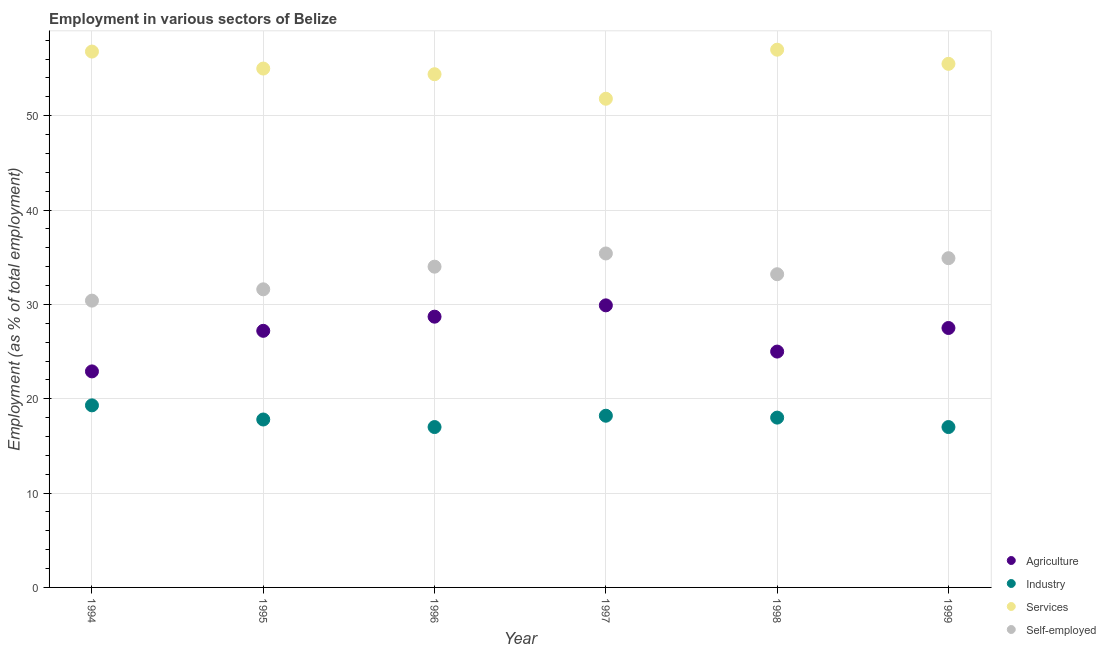Is the number of dotlines equal to the number of legend labels?
Offer a very short reply. Yes. What is the percentage of workers in agriculture in 1994?
Ensure brevity in your answer.  22.9. Across all years, what is the minimum percentage of self employed workers?
Your answer should be very brief. 30.4. In which year was the percentage of workers in agriculture maximum?
Your response must be concise. 1997. In which year was the percentage of self employed workers minimum?
Make the answer very short. 1994. What is the total percentage of workers in industry in the graph?
Your response must be concise. 107.3. What is the difference between the percentage of self employed workers in 1995 and that in 1997?
Offer a very short reply. -3.8. What is the difference between the percentage of workers in services in 1998 and the percentage of workers in industry in 1996?
Your answer should be very brief. 40. What is the average percentage of workers in services per year?
Offer a very short reply. 55.08. In the year 1995, what is the difference between the percentage of workers in services and percentage of workers in industry?
Keep it short and to the point. 37.2. What is the ratio of the percentage of self employed workers in 1995 to that in 1998?
Offer a very short reply. 0.95. Is the percentage of workers in industry in 1998 less than that in 1999?
Give a very brief answer. No. What is the difference between the highest and the second highest percentage of self employed workers?
Your response must be concise. 0.5. What is the difference between the highest and the lowest percentage of workers in industry?
Make the answer very short. 2.3. In how many years, is the percentage of workers in agriculture greater than the average percentage of workers in agriculture taken over all years?
Give a very brief answer. 4. Is it the case that in every year, the sum of the percentage of workers in agriculture and percentage of workers in industry is greater than the sum of percentage of self employed workers and percentage of workers in services?
Your answer should be compact. No. Is it the case that in every year, the sum of the percentage of workers in agriculture and percentage of workers in industry is greater than the percentage of workers in services?
Your answer should be very brief. No. Is the percentage of workers in industry strictly greater than the percentage of self employed workers over the years?
Offer a terse response. No. Is the percentage of workers in industry strictly less than the percentage of workers in agriculture over the years?
Your answer should be compact. Yes. How many dotlines are there?
Offer a very short reply. 4. How many years are there in the graph?
Your response must be concise. 6. Are the values on the major ticks of Y-axis written in scientific E-notation?
Your answer should be compact. No. Does the graph contain grids?
Keep it short and to the point. Yes. Where does the legend appear in the graph?
Your response must be concise. Bottom right. How many legend labels are there?
Offer a very short reply. 4. What is the title of the graph?
Make the answer very short. Employment in various sectors of Belize. Does "Tertiary education" appear as one of the legend labels in the graph?
Your response must be concise. No. What is the label or title of the Y-axis?
Your response must be concise. Employment (as % of total employment). What is the Employment (as % of total employment) in Agriculture in 1994?
Offer a terse response. 22.9. What is the Employment (as % of total employment) of Industry in 1994?
Keep it short and to the point. 19.3. What is the Employment (as % of total employment) in Services in 1994?
Your answer should be compact. 56.8. What is the Employment (as % of total employment) in Self-employed in 1994?
Keep it short and to the point. 30.4. What is the Employment (as % of total employment) in Agriculture in 1995?
Keep it short and to the point. 27.2. What is the Employment (as % of total employment) of Industry in 1995?
Make the answer very short. 17.8. What is the Employment (as % of total employment) in Services in 1995?
Offer a very short reply. 55. What is the Employment (as % of total employment) of Self-employed in 1995?
Provide a short and direct response. 31.6. What is the Employment (as % of total employment) of Agriculture in 1996?
Provide a short and direct response. 28.7. What is the Employment (as % of total employment) of Services in 1996?
Make the answer very short. 54.4. What is the Employment (as % of total employment) in Self-employed in 1996?
Give a very brief answer. 34. What is the Employment (as % of total employment) of Agriculture in 1997?
Ensure brevity in your answer.  29.9. What is the Employment (as % of total employment) in Industry in 1997?
Your answer should be very brief. 18.2. What is the Employment (as % of total employment) in Services in 1997?
Offer a very short reply. 51.8. What is the Employment (as % of total employment) of Self-employed in 1997?
Make the answer very short. 35.4. What is the Employment (as % of total employment) of Services in 1998?
Your response must be concise. 57. What is the Employment (as % of total employment) of Self-employed in 1998?
Offer a terse response. 33.2. What is the Employment (as % of total employment) of Agriculture in 1999?
Your response must be concise. 27.5. What is the Employment (as % of total employment) in Services in 1999?
Make the answer very short. 55.5. What is the Employment (as % of total employment) of Self-employed in 1999?
Your answer should be compact. 34.9. Across all years, what is the maximum Employment (as % of total employment) of Agriculture?
Provide a short and direct response. 29.9. Across all years, what is the maximum Employment (as % of total employment) of Industry?
Offer a very short reply. 19.3. Across all years, what is the maximum Employment (as % of total employment) in Services?
Keep it short and to the point. 57. Across all years, what is the maximum Employment (as % of total employment) of Self-employed?
Give a very brief answer. 35.4. Across all years, what is the minimum Employment (as % of total employment) in Agriculture?
Offer a terse response. 22.9. Across all years, what is the minimum Employment (as % of total employment) in Industry?
Ensure brevity in your answer.  17. Across all years, what is the minimum Employment (as % of total employment) of Services?
Provide a succinct answer. 51.8. Across all years, what is the minimum Employment (as % of total employment) of Self-employed?
Your response must be concise. 30.4. What is the total Employment (as % of total employment) of Agriculture in the graph?
Your answer should be very brief. 161.2. What is the total Employment (as % of total employment) of Industry in the graph?
Your answer should be very brief. 107.3. What is the total Employment (as % of total employment) in Services in the graph?
Your answer should be very brief. 330.5. What is the total Employment (as % of total employment) in Self-employed in the graph?
Provide a short and direct response. 199.5. What is the difference between the Employment (as % of total employment) in Industry in 1994 and that in 1995?
Ensure brevity in your answer.  1.5. What is the difference between the Employment (as % of total employment) in Services in 1994 and that in 1995?
Offer a very short reply. 1.8. What is the difference between the Employment (as % of total employment) in Agriculture in 1994 and that in 1996?
Keep it short and to the point. -5.8. What is the difference between the Employment (as % of total employment) of Services in 1994 and that in 1996?
Give a very brief answer. 2.4. What is the difference between the Employment (as % of total employment) of Self-employed in 1994 and that in 1996?
Provide a short and direct response. -3.6. What is the difference between the Employment (as % of total employment) in Agriculture in 1994 and that in 1997?
Ensure brevity in your answer.  -7. What is the difference between the Employment (as % of total employment) in Industry in 1994 and that in 1997?
Your response must be concise. 1.1. What is the difference between the Employment (as % of total employment) in Services in 1994 and that in 1997?
Offer a terse response. 5. What is the difference between the Employment (as % of total employment) of Agriculture in 1994 and that in 1998?
Ensure brevity in your answer.  -2.1. What is the difference between the Employment (as % of total employment) in Industry in 1994 and that in 1998?
Make the answer very short. 1.3. What is the difference between the Employment (as % of total employment) in Self-employed in 1994 and that in 1998?
Your response must be concise. -2.8. What is the difference between the Employment (as % of total employment) of Industry in 1994 and that in 1999?
Ensure brevity in your answer.  2.3. What is the difference between the Employment (as % of total employment) in Self-employed in 1994 and that in 1999?
Your answer should be very brief. -4.5. What is the difference between the Employment (as % of total employment) of Agriculture in 1995 and that in 1998?
Keep it short and to the point. 2.2. What is the difference between the Employment (as % of total employment) in Industry in 1995 and that in 1998?
Your response must be concise. -0.2. What is the difference between the Employment (as % of total employment) of Services in 1995 and that in 1998?
Keep it short and to the point. -2. What is the difference between the Employment (as % of total employment) in Agriculture in 1995 and that in 1999?
Your response must be concise. -0.3. What is the difference between the Employment (as % of total employment) in Services in 1995 and that in 1999?
Your answer should be very brief. -0.5. What is the difference between the Employment (as % of total employment) of Agriculture in 1996 and that in 1997?
Provide a short and direct response. -1.2. What is the difference between the Employment (as % of total employment) of Industry in 1996 and that in 1997?
Offer a terse response. -1.2. What is the difference between the Employment (as % of total employment) of Industry in 1996 and that in 1998?
Ensure brevity in your answer.  -1. What is the difference between the Employment (as % of total employment) of Services in 1996 and that in 1998?
Provide a succinct answer. -2.6. What is the difference between the Employment (as % of total employment) of Agriculture in 1996 and that in 1999?
Give a very brief answer. 1.2. What is the difference between the Employment (as % of total employment) of Agriculture in 1997 and that in 1998?
Provide a short and direct response. 4.9. What is the difference between the Employment (as % of total employment) in Industry in 1997 and that in 1998?
Offer a very short reply. 0.2. What is the difference between the Employment (as % of total employment) of Services in 1997 and that in 1998?
Offer a very short reply. -5.2. What is the difference between the Employment (as % of total employment) in Self-employed in 1997 and that in 1998?
Your response must be concise. 2.2. What is the difference between the Employment (as % of total employment) of Industry in 1997 and that in 1999?
Make the answer very short. 1.2. What is the difference between the Employment (as % of total employment) in Services in 1997 and that in 1999?
Provide a succinct answer. -3.7. What is the difference between the Employment (as % of total employment) of Self-employed in 1997 and that in 1999?
Your answer should be compact. 0.5. What is the difference between the Employment (as % of total employment) in Agriculture in 1998 and that in 1999?
Make the answer very short. -2.5. What is the difference between the Employment (as % of total employment) of Industry in 1998 and that in 1999?
Offer a very short reply. 1. What is the difference between the Employment (as % of total employment) in Services in 1998 and that in 1999?
Make the answer very short. 1.5. What is the difference between the Employment (as % of total employment) of Agriculture in 1994 and the Employment (as % of total employment) of Services in 1995?
Provide a succinct answer. -32.1. What is the difference between the Employment (as % of total employment) of Industry in 1994 and the Employment (as % of total employment) of Services in 1995?
Keep it short and to the point. -35.7. What is the difference between the Employment (as % of total employment) of Industry in 1994 and the Employment (as % of total employment) of Self-employed in 1995?
Provide a short and direct response. -12.3. What is the difference between the Employment (as % of total employment) in Services in 1994 and the Employment (as % of total employment) in Self-employed in 1995?
Your answer should be very brief. 25.2. What is the difference between the Employment (as % of total employment) of Agriculture in 1994 and the Employment (as % of total employment) of Industry in 1996?
Your answer should be compact. 5.9. What is the difference between the Employment (as % of total employment) in Agriculture in 1994 and the Employment (as % of total employment) in Services in 1996?
Give a very brief answer. -31.5. What is the difference between the Employment (as % of total employment) of Agriculture in 1994 and the Employment (as % of total employment) of Self-employed in 1996?
Offer a very short reply. -11.1. What is the difference between the Employment (as % of total employment) of Industry in 1994 and the Employment (as % of total employment) of Services in 1996?
Your response must be concise. -35.1. What is the difference between the Employment (as % of total employment) in Industry in 1994 and the Employment (as % of total employment) in Self-employed in 1996?
Provide a succinct answer. -14.7. What is the difference between the Employment (as % of total employment) of Services in 1994 and the Employment (as % of total employment) of Self-employed in 1996?
Your response must be concise. 22.8. What is the difference between the Employment (as % of total employment) of Agriculture in 1994 and the Employment (as % of total employment) of Industry in 1997?
Provide a succinct answer. 4.7. What is the difference between the Employment (as % of total employment) of Agriculture in 1994 and the Employment (as % of total employment) of Services in 1997?
Make the answer very short. -28.9. What is the difference between the Employment (as % of total employment) in Agriculture in 1994 and the Employment (as % of total employment) in Self-employed in 1997?
Make the answer very short. -12.5. What is the difference between the Employment (as % of total employment) in Industry in 1994 and the Employment (as % of total employment) in Services in 1997?
Ensure brevity in your answer.  -32.5. What is the difference between the Employment (as % of total employment) of Industry in 1994 and the Employment (as % of total employment) of Self-employed in 1997?
Your response must be concise. -16.1. What is the difference between the Employment (as % of total employment) in Services in 1994 and the Employment (as % of total employment) in Self-employed in 1997?
Your answer should be compact. 21.4. What is the difference between the Employment (as % of total employment) in Agriculture in 1994 and the Employment (as % of total employment) in Industry in 1998?
Ensure brevity in your answer.  4.9. What is the difference between the Employment (as % of total employment) in Agriculture in 1994 and the Employment (as % of total employment) in Services in 1998?
Keep it short and to the point. -34.1. What is the difference between the Employment (as % of total employment) of Agriculture in 1994 and the Employment (as % of total employment) of Self-employed in 1998?
Give a very brief answer. -10.3. What is the difference between the Employment (as % of total employment) in Industry in 1994 and the Employment (as % of total employment) in Services in 1998?
Ensure brevity in your answer.  -37.7. What is the difference between the Employment (as % of total employment) of Services in 1994 and the Employment (as % of total employment) of Self-employed in 1998?
Offer a very short reply. 23.6. What is the difference between the Employment (as % of total employment) of Agriculture in 1994 and the Employment (as % of total employment) of Services in 1999?
Offer a terse response. -32.6. What is the difference between the Employment (as % of total employment) in Agriculture in 1994 and the Employment (as % of total employment) in Self-employed in 1999?
Your answer should be compact. -12. What is the difference between the Employment (as % of total employment) in Industry in 1994 and the Employment (as % of total employment) in Services in 1999?
Your response must be concise. -36.2. What is the difference between the Employment (as % of total employment) in Industry in 1994 and the Employment (as % of total employment) in Self-employed in 1999?
Keep it short and to the point. -15.6. What is the difference between the Employment (as % of total employment) in Services in 1994 and the Employment (as % of total employment) in Self-employed in 1999?
Provide a short and direct response. 21.9. What is the difference between the Employment (as % of total employment) in Agriculture in 1995 and the Employment (as % of total employment) in Industry in 1996?
Your answer should be compact. 10.2. What is the difference between the Employment (as % of total employment) of Agriculture in 1995 and the Employment (as % of total employment) of Services in 1996?
Your response must be concise. -27.2. What is the difference between the Employment (as % of total employment) of Agriculture in 1995 and the Employment (as % of total employment) of Self-employed in 1996?
Your answer should be compact. -6.8. What is the difference between the Employment (as % of total employment) in Industry in 1995 and the Employment (as % of total employment) in Services in 1996?
Make the answer very short. -36.6. What is the difference between the Employment (as % of total employment) of Industry in 1995 and the Employment (as % of total employment) of Self-employed in 1996?
Give a very brief answer. -16.2. What is the difference between the Employment (as % of total employment) in Agriculture in 1995 and the Employment (as % of total employment) in Services in 1997?
Your answer should be very brief. -24.6. What is the difference between the Employment (as % of total employment) in Industry in 1995 and the Employment (as % of total employment) in Services in 1997?
Your answer should be compact. -34. What is the difference between the Employment (as % of total employment) of Industry in 1995 and the Employment (as % of total employment) of Self-employed in 1997?
Provide a short and direct response. -17.6. What is the difference between the Employment (as % of total employment) of Services in 1995 and the Employment (as % of total employment) of Self-employed in 1997?
Ensure brevity in your answer.  19.6. What is the difference between the Employment (as % of total employment) in Agriculture in 1995 and the Employment (as % of total employment) in Services in 1998?
Your response must be concise. -29.8. What is the difference between the Employment (as % of total employment) in Industry in 1995 and the Employment (as % of total employment) in Services in 1998?
Give a very brief answer. -39.2. What is the difference between the Employment (as % of total employment) of Industry in 1995 and the Employment (as % of total employment) of Self-employed in 1998?
Your response must be concise. -15.4. What is the difference between the Employment (as % of total employment) in Services in 1995 and the Employment (as % of total employment) in Self-employed in 1998?
Your response must be concise. 21.8. What is the difference between the Employment (as % of total employment) of Agriculture in 1995 and the Employment (as % of total employment) of Services in 1999?
Your response must be concise. -28.3. What is the difference between the Employment (as % of total employment) in Industry in 1995 and the Employment (as % of total employment) in Services in 1999?
Provide a succinct answer. -37.7. What is the difference between the Employment (as % of total employment) of Industry in 1995 and the Employment (as % of total employment) of Self-employed in 1999?
Make the answer very short. -17.1. What is the difference between the Employment (as % of total employment) in Services in 1995 and the Employment (as % of total employment) in Self-employed in 1999?
Offer a very short reply. 20.1. What is the difference between the Employment (as % of total employment) in Agriculture in 1996 and the Employment (as % of total employment) in Industry in 1997?
Provide a succinct answer. 10.5. What is the difference between the Employment (as % of total employment) of Agriculture in 1996 and the Employment (as % of total employment) of Services in 1997?
Make the answer very short. -23.1. What is the difference between the Employment (as % of total employment) of Agriculture in 1996 and the Employment (as % of total employment) of Self-employed in 1997?
Your answer should be compact. -6.7. What is the difference between the Employment (as % of total employment) in Industry in 1996 and the Employment (as % of total employment) in Services in 1997?
Your answer should be very brief. -34.8. What is the difference between the Employment (as % of total employment) of Industry in 1996 and the Employment (as % of total employment) of Self-employed in 1997?
Offer a terse response. -18.4. What is the difference between the Employment (as % of total employment) of Services in 1996 and the Employment (as % of total employment) of Self-employed in 1997?
Your response must be concise. 19. What is the difference between the Employment (as % of total employment) of Agriculture in 1996 and the Employment (as % of total employment) of Industry in 1998?
Make the answer very short. 10.7. What is the difference between the Employment (as % of total employment) of Agriculture in 1996 and the Employment (as % of total employment) of Services in 1998?
Give a very brief answer. -28.3. What is the difference between the Employment (as % of total employment) in Agriculture in 1996 and the Employment (as % of total employment) in Self-employed in 1998?
Ensure brevity in your answer.  -4.5. What is the difference between the Employment (as % of total employment) of Industry in 1996 and the Employment (as % of total employment) of Services in 1998?
Provide a succinct answer. -40. What is the difference between the Employment (as % of total employment) in Industry in 1996 and the Employment (as % of total employment) in Self-employed in 1998?
Your answer should be very brief. -16.2. What is the difference between the Employment (as % of total employment) in Services in 1996 and the Employment (as % of total employment) in Self-employed in 1998?
Provide a succinct answer. 21.2. What is the difference between the Employment (as % of total employment) in Agriculture in 1996 and the Employment (as % of total employment) in Services in 1999?
Keep it short and to the point. -26.8. What is the difference between the Employment (as % of total employment) of Industry in 1996 and the Employment (as % of total employment) of Services in 1999?
Your answer should be very brief. -38.5. What is the difference between the Employment (as % of total employment) in Industry in 1996 and the Employment (as % of total employment) in Self-employed in 1999?
Ensure brevity in your answer.  -17.9. What is the difference between the Employment (as % of total employment) of Agriculture in 1997 and the Employment (as % of total employment) of Industry in 1998?
Ensure brevity in your answer.  11.9. What is the difference between the Employment (as % of total employment) of Agriculture in 1997 and the Employment (as % of total employment) of Services in 1998?
Provide a short and direct response. -27.1. What is the difference between the Employment (as % of total employment) in Industry in 1997 and the Employment (as % of total employment) in Services in 1998?
Ensure brevity in your answer.  -38.8. What is the difference between the Employment (as % of total employment) in Agriculture in 1997 and the Employment (as % of total employment) in Industry in 1999?
Offer a very short reply. 12.9. What is the difference between the Employment (as % of total employment) in Agriculture in 1997 and the Employment (as % of total employment) in Services in 1999?
Make the answer very short. -25.6. What is the difference between the Employment (as % of total employment) of Agriculture in 1997 and the Employment (as % of total employment) of Self-employed in 1999?
Give a very brief answer. -5. What is the difference between the Employment (as % of total employment) of Industry in 1997 and the Employment (as % of total employment) of Services in 1999?
Your answer should be compact. -37.3. What is the difference between the Employment (as % of total employment) in Industry in 1997 and the Employment (as % of total employment) in Self-employed in 1999?
Your answer should be very brief. -16.7. What is the difference between the Employment (as % of total employment) in Services in 1997 and the Employment (as % of total employment) in Self-employed in 1999?
Offer a very short reply. 16.9. What is the difference between the Employment (as % of total employment) of Agriculture in 1998 and the Employment (as % of total employment) of Industry in 1999?
Give a very brief answer. 8. What is the difference between the Employment (as % of total employment) in Agriculture in 1998 and the Employment (as % of total employment) in Services in 1999?
Your answer should be compact. -30.5. What is the difference between the Employment (as % of total employment) of Industry in 1998 and the Employment (as % of total employment) of Services in 1999?
Offer a very short reply. -37.5. What is the difference between the Employment (as % of total employment) in Industry in 1998 and the Employment (as % of total employment) in Self-employed in 1999?
Make the answer very short. -16.9. What is the difference between the Employment (as % of total employment) in Services in 1998 and the Employment (as % of total employment) in Self-employed in 1999?
Provide a succinct answer. 22.1. What is the average Employment (as % of total employment) in Agriculture per year?
Offer a very short reply. 26.87. What is the average Employment (as % of total employment) of Industry per year?
Provide a succinct answer. 17.88. What is the average Employment (as % of total employment) in Services per year?
Your answer should be very brief. 55.08. What is the average Employment (as % of total employment) of Self-employed per year?
Provide a succinct answer. 33.25. In the year 1994, what is the difference between the Employment (as % of total employment) of Agriculture and Employment (as % of total employment) of Services?
Make the answer very short. -33.9. In the year 1994, what is the difference between the Employment (as % of total employment) in Industry and Employment (as % of total employment) in Services?
Provide a short and direct response. -37.5. In the year 1994, what is the difference between the Employment (as % of total employment) of Industry and Employment (as % of total employment) of Self-employed?
Give a very brief answer. -11.1. In the year 1994, what is the difference between the Employment (as % of total employment) in Services and Employment (as % of total employment) in Self-employed?
Make the answer very short. 26.4. In the year 1995, what is the difference between the Employment (as % of total employment) in Agriculture and Employment (as % of total employment) in Industry?
Ensure brevity in your answer.  9.4. In the year 1995, what is the difference between the Employment (as % of total employment) in Agriculture and Employment (as % of total employment) in Services?
Your answer should be very brief. -27.8. In the year 1995, what is the difference between the Employment (as % of total employment) of Agriculture and Employment (as % of total employment) of Self-employed?
Offer a terse response. -4.4. In the year 1995, what is the difference between the Employment (as % of total employment) in Industry and Employment (as % of total employment) in Services?
Make the answer very short. -37.2. In the year 1995, what is the difference between the Employment (as % of total employment) in Services and Employment (as % of total employment) in Self-employed?
Make the answer very short. 23.4. In the year 1996, what is the difference between the Employment (as % of total employment) of Agriculture and Employment (as % of total employment) of Services?
Your response must be concise. -25.7. In the year 1996, what is the difference between the Employment (as % of total employment) of Agriculture and Employment (as % of total employment) of Self-employed?
Your answer should be compact. -5.3. In the year 1996, what is the difference between the Employment (as % of total employment) of Industry and Employment (as % of total employment) of Services?
Offer a terse response. -37.4. In the year 1996, what is the difference between the Employment (as % of total employment) in Industry and Employment (as % of total employment) in Self-employed?
Ensure brevity in your answer.  -17. In the year 1996, what is the difference between the Employment (as % of total employment) in Services and Employment (as % of total employment) in Self-employed?
Keep it short and to the point. 20.4. In the year 1997, what is the difference between the Employment (as % of total employment) of Agriculture and Employment (as % of total employment) of Services?
Offer a very short reply. -21.9. In the year 1997, what is the difference between the Employment (as % of total employment) of Agriculture and Employment (as % of total employment) of Self-employed?
Your answer should be very brief. -5.5. In the year 1997, what is the difference between the Employment (as % of total employment) of Industry and Employment (as % of total employment) of Services?
Your answer should be compact. -33.6. In the year 1997, what is the difference between the Employment (as % of total employment) in Industry and Employment (as % of total employment) in Self-employed?
Provide a short and direct response. -17.2. In the year 1997, what is the difference between the Employment (as % of total employment) of Services and Employment (as % of total employment) of Self-employed?
Your response must be concise. 16.4. In the year 1998, what is the difference between the Employment (as % of total employment) of Agriculture and Employment (as % of total employment) of Services?
Give a very brief answer. -32. In the year 1998, what is the difference between the Employment (as % of total employment) in Agriculture and Employment (as % of total employment) in Self-employed?
Offer a very short reply. -8.2. In the year 1998, what is the difference between the Employment (as % of total employment) of Industry and Employment (as % of total employment) of Services?
Provide a short and direct response. -39. In the year 1998, what is the difference between the Employment (as % of total employment) of Industry and Employment (as % of total employment) of Self-employed?
Your answer should be very brief. -15.2. In the year 1998, what is the difference between the Employment (as % of total employment) of Services and Employment (as % of total employment) of Self-employed?
Keep it short and to the point. 23.8. In the year 1999, what is the difference between the Employment (as % of total employment) of Agriculture and Employment (as % of total employment) of Industry?
Give a very brief answer. 10.5. In the year 1999, what is the difference between the Employment (as % of total employment) of Agriculture and Employment (as % of total employment) of Self-employed?
Provide a short and direct response. -7.4. In the year 1999, what is the difference between the Employment (as % of total employment) in Industry and Employment (as % of total employment) in Services?
Ensure brevity in your answer.  -38.5. In the year 1999, what is the difference between the Employment (as % of total employment) of Industry and Employment (as % of total employment) of Self-employed?
Offer a very short reply. -17.9. In the year 1999, what is the difference between the Employment (as % of total employment) of Services and Employment (as % of total employment) of Self-employed?
Your answer should be very brief. 20.6. What is the ratio of the Employment (as % of total employment) in Agriculture in 1994 to that in 1995?
Your answer should be very brief. 0.84. What is the ratio of the Employment (as % of total employment) in Industry in 1994 to that in 1995?
Give a very brief answer. 1.08. What is the ratio of the Employment (as % of total employment) in Services in 1994 to that in 1995?
Make the answer very short. 1.03. What is the ratio of the Employment (as % of total employment) of Agriculture in 1994 to that in 1996?
Your answer should be compact. 0.8. What is the ratio of the Employment (as % of total employment) in Industry in 1994 to that in 1996?
Give a very brief answer. 1.14. What is the ratio of the Employment (as % of total employment) in Services in 1994 to that in 1996?
Provide a short and direct response. 1.04. What is the ratio of the Employment (as % of total employment) of Self-employed in 1994 to that in 1996?
Make the answer very short. 0.89. What is the ratio of the Employment (as % of total employment) of Agriculture in 1994 to that in 1997?
Offer a terse response. 0.77. What is the ratio of the Employment (as % of total employment) of Industry in 1994 to that in 1997?
Make the answer very short. 1.06. What is the ratio of the Employment (as % of total employment) of Services in 1994 to that in 1997?
Your answer should be compact. 1.1. What is the ratio of the Employment (as % of total employment) of Self-employed in 1994 to that in 1997?
Ensure brevity in your answer.  0.86. What is the ratio of the Employment (as % of total employment) of Agriculture in 1994 to that in 1998?
Your answer should be very brief. 0.92. What is the ratio of the Employment (as % of total employment) of Industry in 1994 to that in 1998?
Provide a succinct answer. 1.07. What is the ratio of the Employment (as % of total employment) in Self-employed in 1994 to that in 1998?
Your answer should be very brief. 0.92. What is the ratio of the Employment (as % of total employment) in Agriculture in 1994 to that in 1999?
Keep it short and to the point. 0.83. What is the ratio of the Employment (as % of total employment) of Industry in 1994 to that in 1999?
Ensure brevity in your answer.  1.14. What is the ratio of the Employment (as % of total employment) of Services in 1994 to that in 1999?
Make the answer very short. 1.02. What is the ratio of the Employment (as % of total employment) of Self-employed in 1994 to that in 1999?
Your response must be concise. 0.87. What is the ratio of the Employment (as % of total employment) of Agriculture in 1995 to that in 1996?
Keep it short and to the point. 0.95. What is the ratio of the Employment (as % of total employment) in Industry in 1995 to that in 1996?
Keep it short and to the point. 1.05. What is the ratio of the Employment (as % of total employment) in Self-employed in 1995 to that in 1996?
Your answer should be very brief. 0.93. What is the ratio of the Employment (as % of total employment) in Agriculture in 1995 to that in 1997?
Your answer should be compact. 0.91. What is the ratio of the Employment (as % of total employment) of Services in 1995 to that in 1997?
Your answer should be very brief. 1.06. What is the ratio of the Employment (as % of total employment) in Self-employed in 1995 to that in 1997?
Your response must be concise. 0.89. What is the ratio of the Employment (as % of total employment) of Agriculture in 1995 to that in 1998?
Give a very brief answer. 1.09. What is the ratio of the Employment (as % of total employment) in Industry in 1995 to that in 1998?
Offer a very short reply. 0.99. What is the ratio of the Employment (as % of total employment) of Services in 1995 to that in 1998?
Offer a very short reply. 0.96. What is the ratio of the Employment (as % of total employment) in Self-employed in 1995 to that in 1998?
Ensure brevity in your answer.  0.95. What is the ratio of the Employment (as % of total employment) of Agriculture in 1995 to that in 1999?
Make the answer very short. 0.99. What is the ratio of the Employment (as % of total employment) of Industry in 1995 to that in 1999?
Your response must be concise. 1.05. What is the ratio of the Employment (as % of total employment) of Services in 1995 to that in 1999?
Give a very brief answer. 0.99. What is the ratio of the Employment (as % of total employment) in Self-employed in 1995 to that in 1999?
Your response must be concise. 0.91. What is the ratio of the Employment (as % of total employment) in Agriculture in 1996 to that in 1997?
Ensure brevity in your answer.  0.96. What is the ratio of the Employment (as % of total employment) in Industry in 1996 to that in 1997?
Your answer should be very brief. 0.93. What is the ratio of the Employment (as % of total employment) in Services in 1996 to that in 1997?
Provide a succinct answer. 1.05. What is the ratio of the Employment (as % of total employment) of Self-employed in 1996 to that in 1997?
Provide a short and direct response. 0.96. What is the ratio of the Employment (as % of total employment) of Agriculture in 1996 to that in 1998?
Your answer should be very brief. 1.15. What is the ratio of the Employment (as % of total employment) in Industry in 1996 to that in 1998?
Provide a short and direct response. 0.94. What is the ratio of the Employment (as % of total employment) of Services in 1996 to that in 1998?
Your answer should be very brief. 0.95. What is the ratio of the Employment (as % of total employment) in Self-employed in 1996 to that in 1998?
Offer a very short reply. 1.02. What is the ratio of the Employment (as % of total employment) of Agriculture in 1996 to that in 1999?
Your response must be concise. 1.04. What is the ratio of the Employment (as % of total employment) in Services in 1996 to that in 1999?
Your answer should be compact. 0.98. What is the ratio of the Employment (as % of total employment) of Self-employed in 1996 to that in 1999?
Make the answer very short. 0.97. What is the ratio of the Employment (as % of total employment) in Agriculture in 1997 to that in 1998?
Your response must be concise. 1.2. What is the ratio of the Employment (as % of total employment) in Industry in 1997 to that in 1998?
Your answer should be very brief. 1.01. What is the ratio of the Employment (as % of total employment) of Services in 1997 to that in 1998?
Provide a succinct answer. 0.91. What is the ratio of the Employment (as % of total employment) in Self-employed in 1997 to that in 1998?
Provide a short and direct response. 1.07. What is the ratio of the Employment (as % of total employment) of Agriculture in 1997 to that in 1999?
Make the answer very short. 1.09. What is the ratio of the Employment (as % of total employment) in Industry in 1997 to that in 1999?
Offer a terse response. 1.07. What is the ratio of the Employment (as % of total employment) of Services in 1997 to that in 1999?
Your answer should be very brief. 0.93. What is the ratio of the Employment (as % of total employment) of Self-employed in 1997 to that in 1999?
Provide a short and direct response. 1.01. What is the ratio of the Employment (as % of total employment) of Agriculture in 1998 to that in 1999?
Your answer should be very brief. 0.91. What is the ratio of the Employment (as % of total employment) in Industry in 1998 to that in 1999?
Give a very brief answer. 1.06. What is the ratio of the Employment (as % of total employment) of Services in 1998 to that in 1999?
Give a very brief answer. 1.03. What is the ratio of the Employment (as % of total employment) of Self-employed in 1998 to that in 1999?
Offer a terse response. 0.95. What is the difference between the highest and the second highest Employment (as % of total employment) of Industry?
Provide a short and direct response. 1.1. What is the difference between the highest and the second highest Employment (as % of total employment) in Services?
Ensure brevity in your answer.  0.2. What is the difference between the highest and the lowest Employment (as % of total employment) of Industry?
Your answer should be compact. 2.3. 